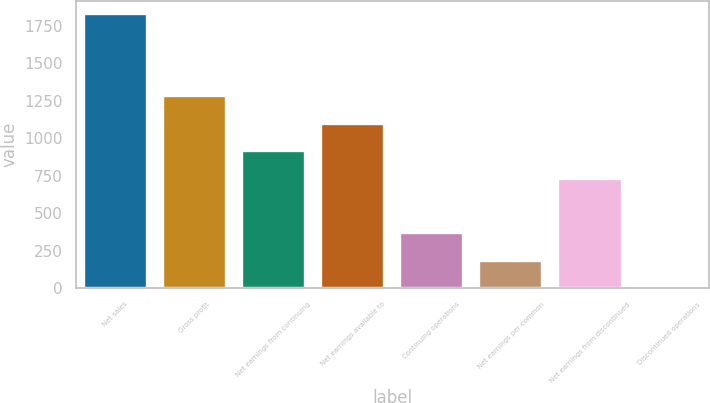Convert chart to OTSL. <chart><loc_0><loc_0><loc_500><loc_500><bar_chart><fcel>Net sales<fcel>Gross profit<fcel>Net earnings from continuing<fcel>Net earnings available to<fcel>Continuing operations<fcel>Net earnings per common<fcel>Net earnings from discontinued<fcel>Discontinued operations<nl><fcel>1827.7<fcel>1279.4<fcel>913.86<fcel>1096.63<fcel>365.55<fcel>182.78<fcel>731.09<fcel>0.01<nl></chart> 